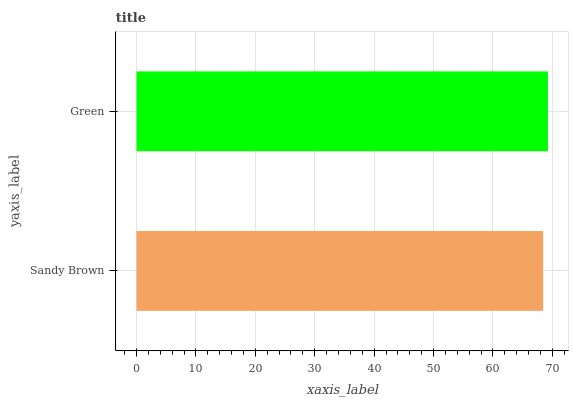Is Sandy Brown the minimum?
Answer yes or no. Yes. Is Green the maximum?
Answer yes or no. Yes. Is Green the minimum?
Answer yes or no. No. Is Green greater than Sandy Brown?
Answer yes or no. Yes. Is Sandy Brown less than Green?
Answer yes or no. Yes. Is Sandy Brown greater than Green?
Answer yes or no. No. Is Green less than Sandy Brown?
Answer yes or no. No. Is Green the high median?
Answer yes or no. Yes. Is Sandy Brown the low median?
Answer yes or no. Yes. Is Sandy Brown the high median?
Answer yes or no. No. Is Green the low median?
Answer yes or no. No. 